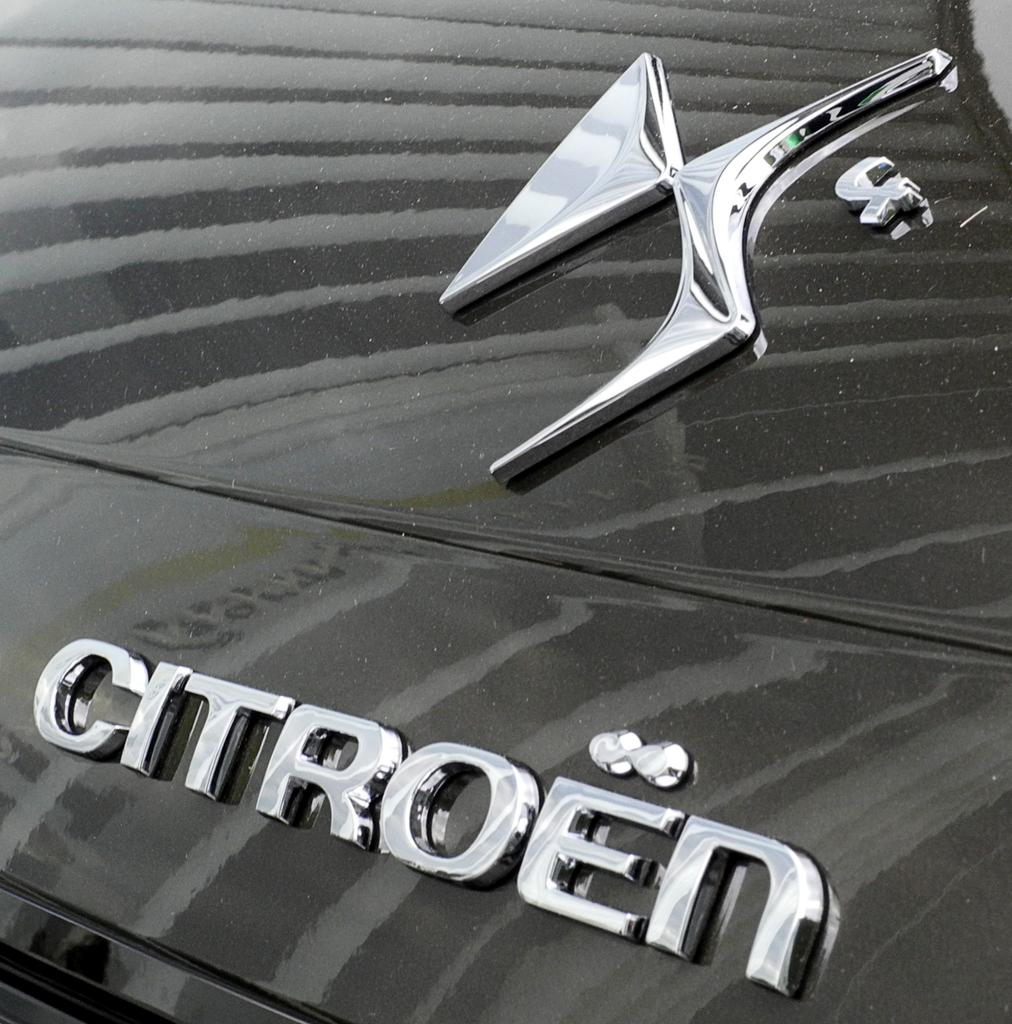What can be seen in the image? There is an object in the image. What is the color of the object? The object is black in color. Is there any writing on the object? Yes, there is text written on the object. Can you hear the match being struck in the image? There is no match or sound present in the image, as it only features a black object with text on it. 